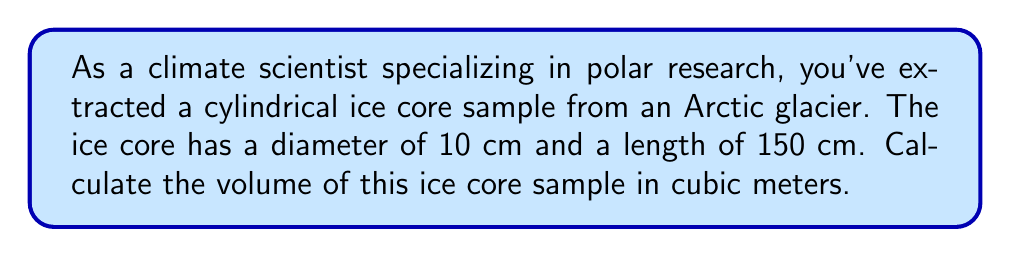What is the answer to this math problem? To calculate the volume of a cylindrical ice core sample, we need to use the formula for the volume of a cylinder:

$$V = \pi r^2 h$$

Where:
$V$ = volume of the cylinder
$r$ = radius of the base
$h$ = height (or length) of the cylinder

Let's break down the problem step-by-step:

1. Identify the given dimensions:
   - Diameter = 10 cm
   - Length = 150 cm

2. Calculate the radius:
   $r = \frac{diameter}{2} = \frac{10 \text{ cm}}{2} = 5 \text{ cm}$

3. Convert the length to meters:
   $h = 150 \text{ cm} = 1.5 \text{ m}$

4. Convert the radius to meters:
   $r = 5 \text{ cm} = 0.05 \text{ m}$

5. Apply the volume formula:
   $$V = \pi r^2 h$$
   $$V = \pi (0.05 \text{ m})^2 (1.5 \text{ m})$$
   $$V = \pi (0.0025 \text{ m}^2) (1.5 \text{ m})$$
   $$V = 0.0037699111843077517 \text{ m}^3$$

6. Round to four decimal places:
   $$V \approx 0.0038 \text{ m}^3$$

[asy]
import geometry;

size(200);
real r = 1;
real h = 3;
path3 p = (0,0,0)--(0,0,h);
revolution cyl = revolution(p,Z);
draw(surface(cyl), paleblue+opacity(0.5));
draw(p, blue);
draw(circle((0,0,0),r), blue);
draw(circle((0,0,h),r), blue);
label("r", (r/2,0,0), E);
label("h", (0,0,h/2), W);
[/asy]
Answer: The volume of the cylindrical ice core sample is approximately $0.0038 \text{ m}^3$. 